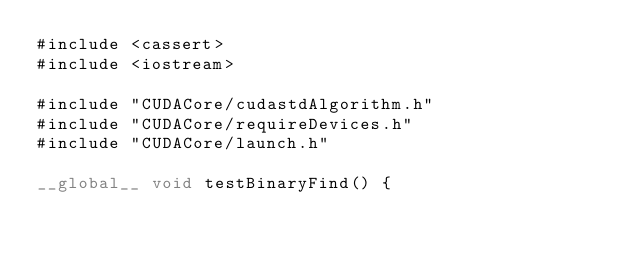Convert code to text. <code><loc_0><loc_0><loc_500><loc_500><_Cuda_>#include <cassert>
#include <iostream>

#include "CUDACore/cudastdAlgorithm.h"
#include "CUDACore/requireDevices.h"
#include "CUDACore/launch.h"

__global__ void testBinaryFind() {</code> 